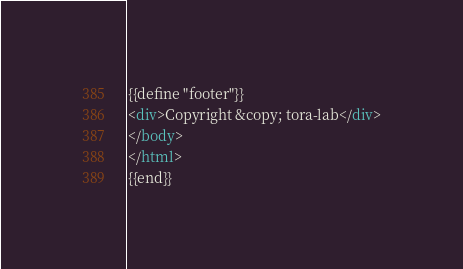Convert code to text. <code><loc_0><loc_0><loc_500><loc_500><_HTML_>{{define "footer"}}
<div>Copyright &copy; tora-lab</div>
</body>
</html>
{{end}}</code> 